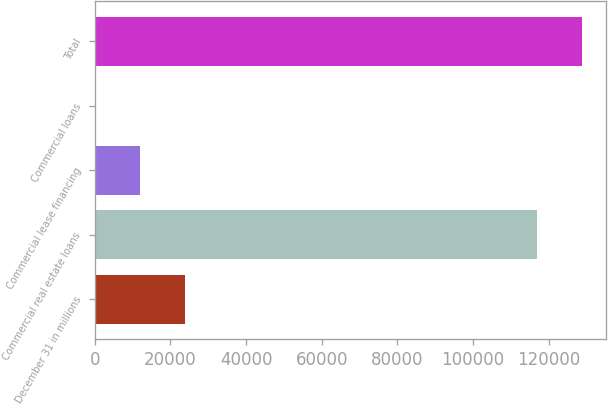Convert chart. <chart><loc_0><loc_0><loc_500><loc_500><bar_chart><fcel>December 31 in millions<fcel>Commercial real estate loans<fcel>Commercial lease financing<fcel>Commercial loans<fcel>Total<nl><fcel>23824.4<fcel>117071<fcel>12046.7<fcel>269<fcel>128849<nl></chart> 